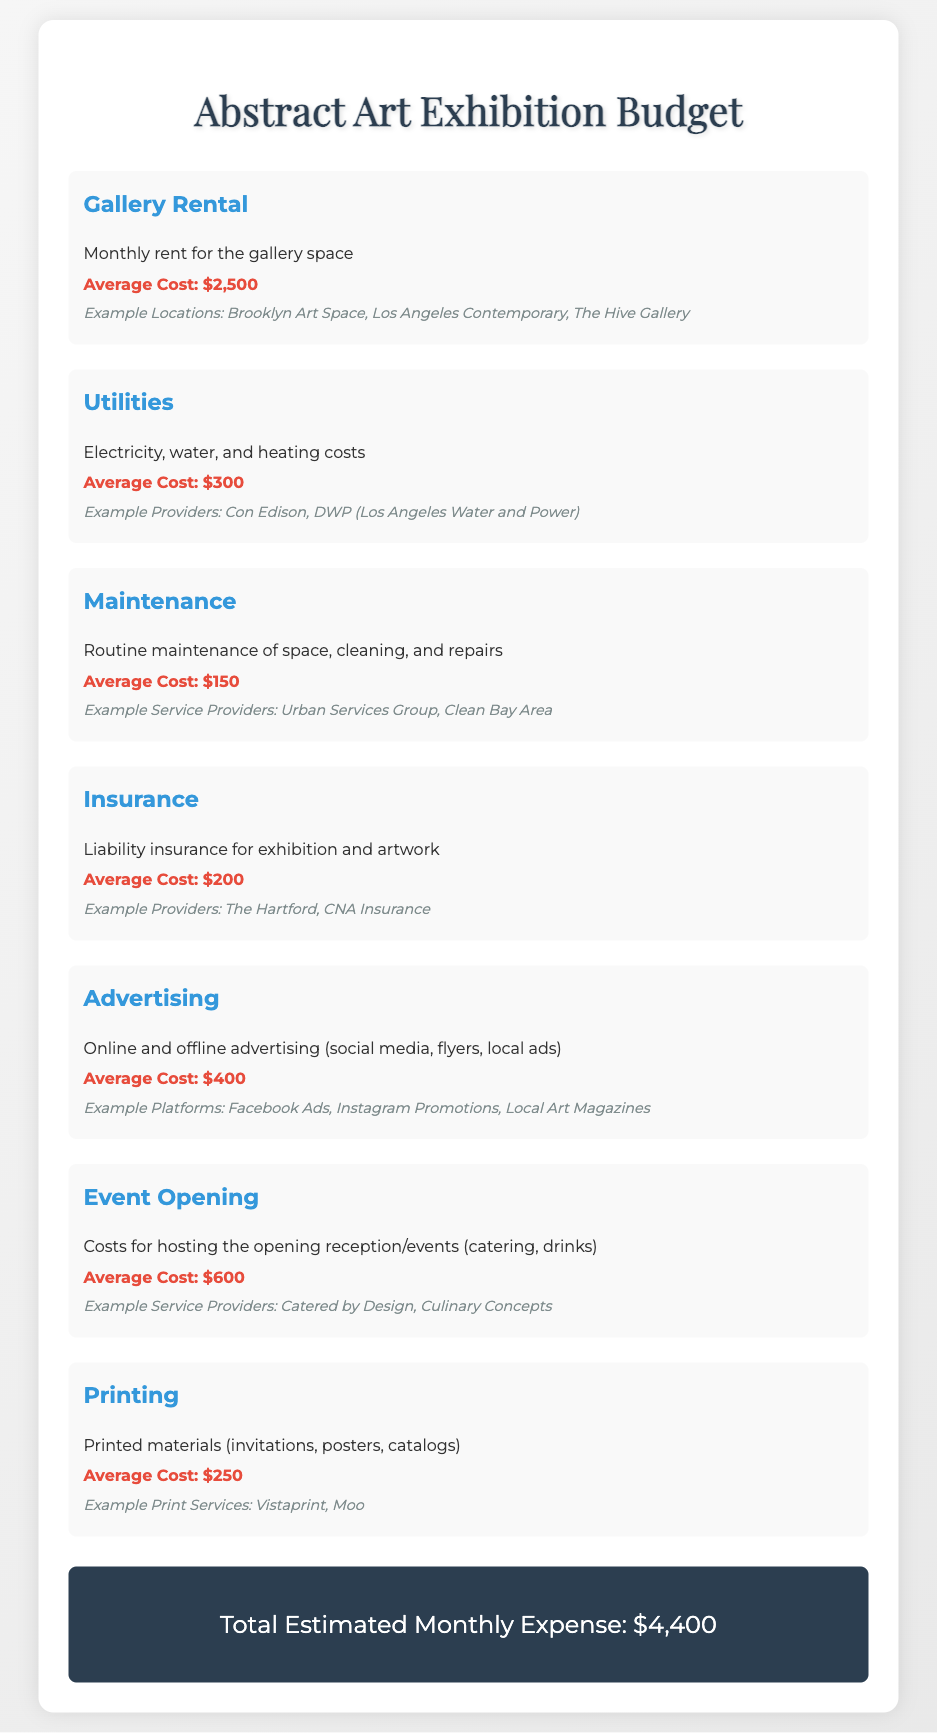What is the average cost of gallery rental? The average cost of gallery rental is provided in the budget section for gallery rental.
Answer: $2,500 How much is allocated for utilities? The budget section outlines the costs for utilities, which includes electricity, water, and heating costs.
Answer: $300 What is the average cost for maintenance? The document specifies the costs related to routine maintenance, cleaning, and repairs under the maintenance section.
Answer: $150 What is the total estimated monthly expense? The document summarizes the total costs of all items listed, providing an overall monthly expense.
Answer: $4,400 What costs are included in the advertising category? The advertising category mentions online and offline advertising efforts, including specific examples of advertising platforms.
Answer: $400 Which service is mentioned for the event opening costs? The document references providers that manage catering and drinks for the opening events under the event opening section.
Answer: Catered by Design How much is the average cost for insurance? The insurance cost is listed in the budget and includes the specific purpose for liability insurance.
Answer: $200 What does the printing category cover? The document indicates that the printing category involves costs associated with printed materials for the exhibition.
Answer: Invitations, posters, catalogs Which budget item has the highest cost? The budget provides a comparison of costs across different categories, allowing for the identification of the highest expense.
Answer: Gallery Rental 